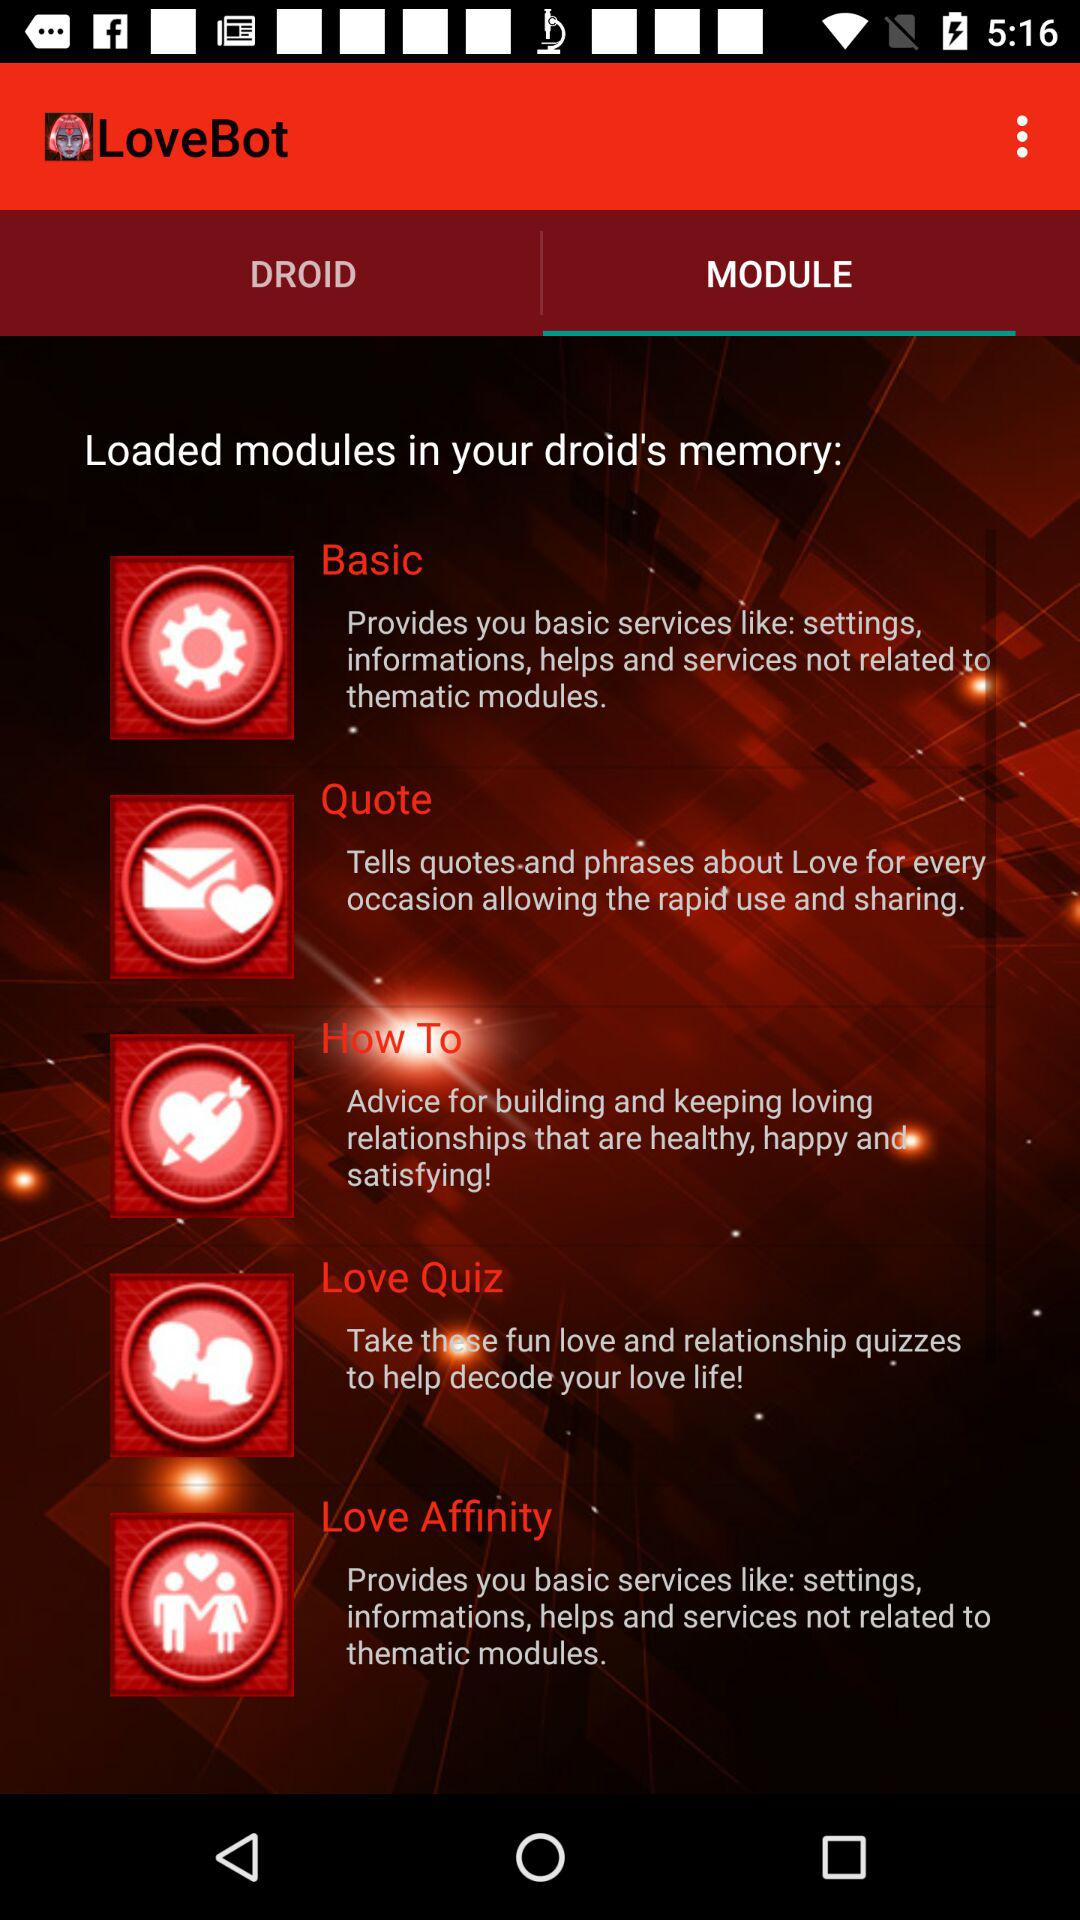How many items are in "DROID"?
When the provided information is insufficient, respond with <no answer>. <no answer> 